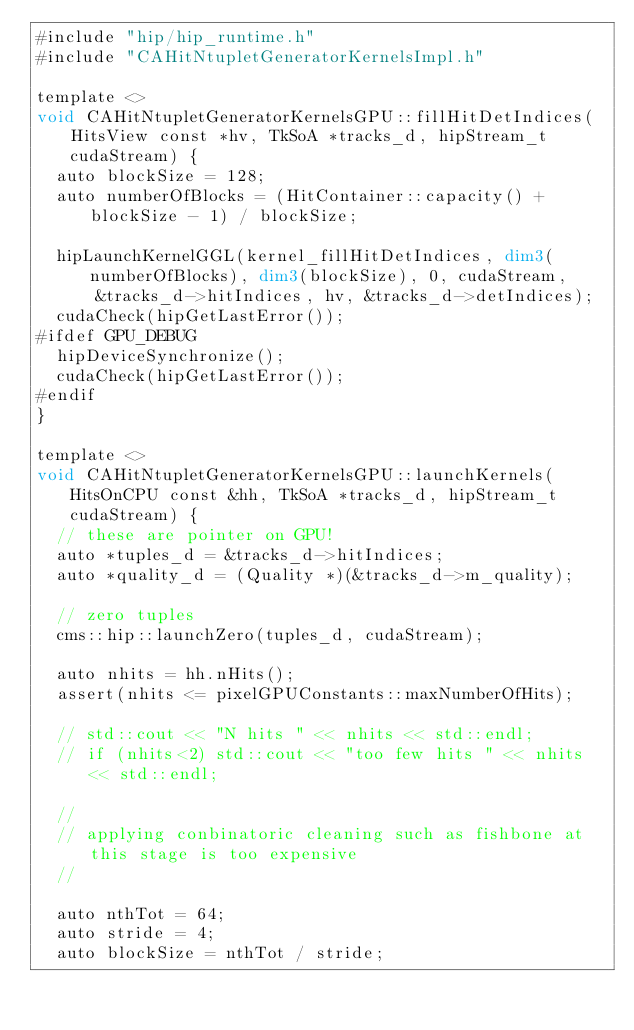<code> <loc_0><loc_0><loc_500><loc_500><_Cuda_>#include "hip/hip_runtime.h"
#include "CAHitNtupletGeneratorKernelsImpl.h"

template <>
void CAHitNtupletGeneratorKernelsGPU::fillHitDetIndices(HitsView const *hv, TkSoA *tracks_d, hipStream_t cudaStream) {
  auto blockSize = 128;
  auto numberOfBlocks = (HitContainer::capacity() + blockSize - 1) / blockSize;

  hipLaunchKernelGGL(kernel_fillHitDetIndices, dim3(numberOfBlocks), dim3(blockSize), 0, cudaStream, 
      &tracks_d->hitIndices, hv, &tracks_d->detIndices);
  cudaCheck(hipGetLastError());
#ifdef GPU_DEBUG
  hipDeviceSynchronize();
  cudaCheck(hipGetLastError());
#endif
}

template <>
void CAHitNtupletGeneratorKernelsGPU::launchKernels(HitsOnCPU const &hh, TkSoA *tracks_d, hipStream_t cudaStream) {
  // these are pointer on GPU!
  auto *tuples_d = &tracks_d->hitIndices;
  auto *quality_d = (Quality *)(&tracks_d->m_quality);

  // zero tuples
  cms::hip::launchZero(tuples_d, cudaStream);

  auto nhits = hh.nHits();
  assert(nhits <= pixelGPUConstants::maxNumberOfHits);

  // std::cout << "N hits " << nhits << std::endl;
  // if (nhits<2) std::cout << "too few hits " << nhits << std::endl;

  //
  // applying conbinatoric cleaning such as fishbone at this stage is too expensive
  //

  auto nthTot = 64;
  auto stride = 4;
  auto blockSize = nthTot / stride;</code> 